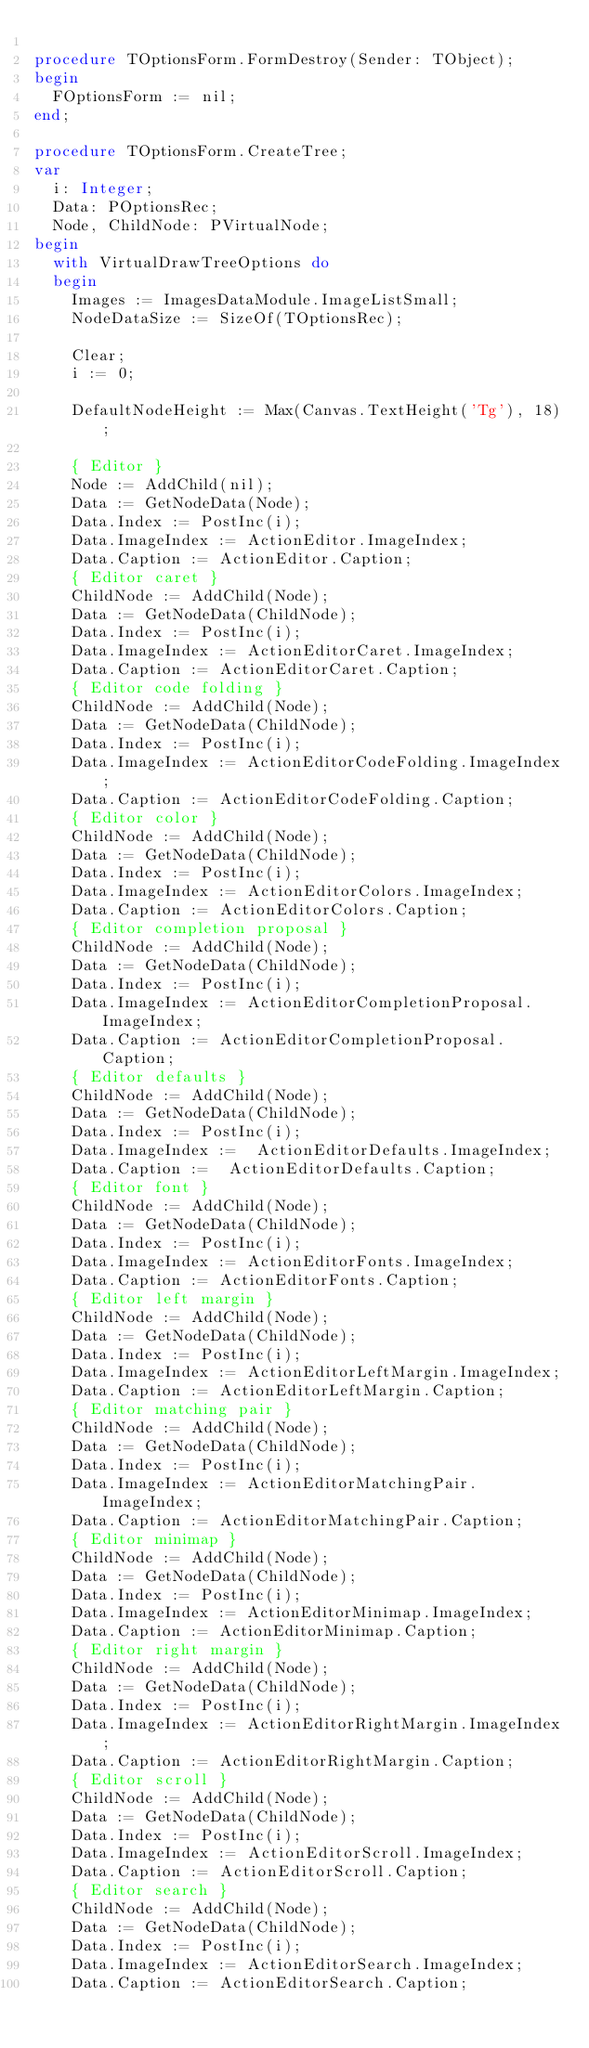<code> <loc_0><loc_0><loc_500><loc_500><_Pascal_>
procedure TOptionsForm.FormDestroy(Sender: TObject);
begin
  FOptionsForm := nil;
end;

procedure TOptionsForm.CreateTree;
var
  i: Integer;
  Data: POptionsRec;
  Node, ChildNode: PVirtualNode;
begin
  with VirtualDrawTreeOptions do
  begin
    Images := ImagesDataModule.ImageListSmall;
    NodeDataSize := SizeOf(TOptionsRec);

    Clear;
    i := 0;

    DefaultNodeHeight := Max(Canvas.TextHeight('Tg'), 18);

    { Editor }
    Node := AddChild(nil);
    Data := GetNodeData(Node);
    Data.Index := PostInc(i);
    Data.ImageIndex := ActionEditor.ImageIndex;
    Data.Caption := ActionEditor.Caption;
    { Editor caret }
    ChildNode := AddChild(Node);
    Data := GetNodeData(ChildNode);
    Data.Index := PostInc(i);
    Data.ImageIndex := ActionEditorCaret.ImageIndex;
    Data.Caption := ActionEditorCaret.Caption;
    { Editor code folding }
    ChildNode := AddChild(Node);
    Data := GetNodeData(ChildNode);
    Data.Index := PostInc(i);
    Data.ImageIndex := ActionEditorCodeFolding.ImageIndex;
    Data.Caption := ActionEditorCodeFolding.Caption;
    { Editor color }
    ChildNode := AddChild(Node);
    Data := GetNodeData(ChildNode);
    Data.Index := PostInc(i);
    Data.ImageIndex := ActionEditorColors.ImageIndex;
    Data.Caption := ActionEditorColors.Caption;
    { Editor completion proposal }
    ChildNode := AddChild(Node);
    Data := GetNodeData(ChildNode);
    Data.Index := PostInc(i);
    Data.ImageIndex := ActionEditorCompletionProposal.ImageIndex;
    Data.Caption := ActionEditorCompletionProposal.Caption;
    { Editor defaults }
    ChildNode := AddChild(Node);
    Data := GetNodeData(ChildNode);
    Data.Index := PostInc(i);
    Data.ImageIndex :=  ActionEditorDefaults.ImageIndex;
    Data.Caption :=  ActionEditorDefaults.Caption;
    { Editor font }
    ChildNode := AddChild(Node);
    Data := GetNodeData(ChildNode);
    Data.Index := PostInc(i);
    Data.ImageIndex := ActionEditorFonts.ImageIndex;
    Data.Caption := ActionEditorFonts.Caption;
    { Editor left margin }
    ChildNode := AddChild(Node);
    Data := GetNodeData(ChildNode);
    Data.Index := PostInc(i);
    Data.ImageIndex := ActionEditorLeftMargin.ImageIndex;
    Data.Caption := ActionEditorLeftMargin.Caption;
    { Editor matching pair }
    ChildNode := AddChild(Node);
    Data := GetNodeData(ChildNode);
    Data.Index := PostInc(i);
    Data.ImageIndex := ActionEditorMatchingPair.ImageIndex;
    Data.Caption := ActionEditorMatchingPair.Caption;
    { Editor minimap }
    ChildNode := AddChild(Node);
    Data := GetNodeData(ChildNode);
    Data.Index := PostInc(i);
    Data.ImageIndex := ActionEditorMinimap.ImageIndex;
    Data.Caption := ActionEditorMinimap.Caption;
    { Editor right margin }
    ChildNode := AddChild(Node);
    Data := GetNodeData(ChildNode);
    Data.Index := PostInc(i);
    Data.ImageIndex := ActionEditorRightMargin.ImageIndex;
    Data.Caption := ActionEditorRightMargin.Caption;
    { Editor scroll }
    ChildNode := AddChild(Node);
    Data := GetNodeData(ChildNode);
    Data.Index := PostInc(i);
    Data.ImageIndex := ActionEditorScroll.ImageIndex;
    Data.Caption := ActionEditorScroll.Caption;
    { Editor search }
    ChildNode := AddChild(Node);
    Data := GetNodeData(ChildNode);
    Data.Index := PostInc(i);
    Data.ImageIndex := ActionEditorSearch.ImageIndex;
    Data.Caption := ActionEditorSearch.Caption;</code> 